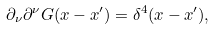Convert formula to latex. <formula><loc_0><loc_0><loc_500><loc_500>\partial _ { \nu } \partial ^ { \nu } G ( x - x ^ { \prime } ) = \delta ^ { 4 } ( x - x ^ { \prime } ) ,</formula> 